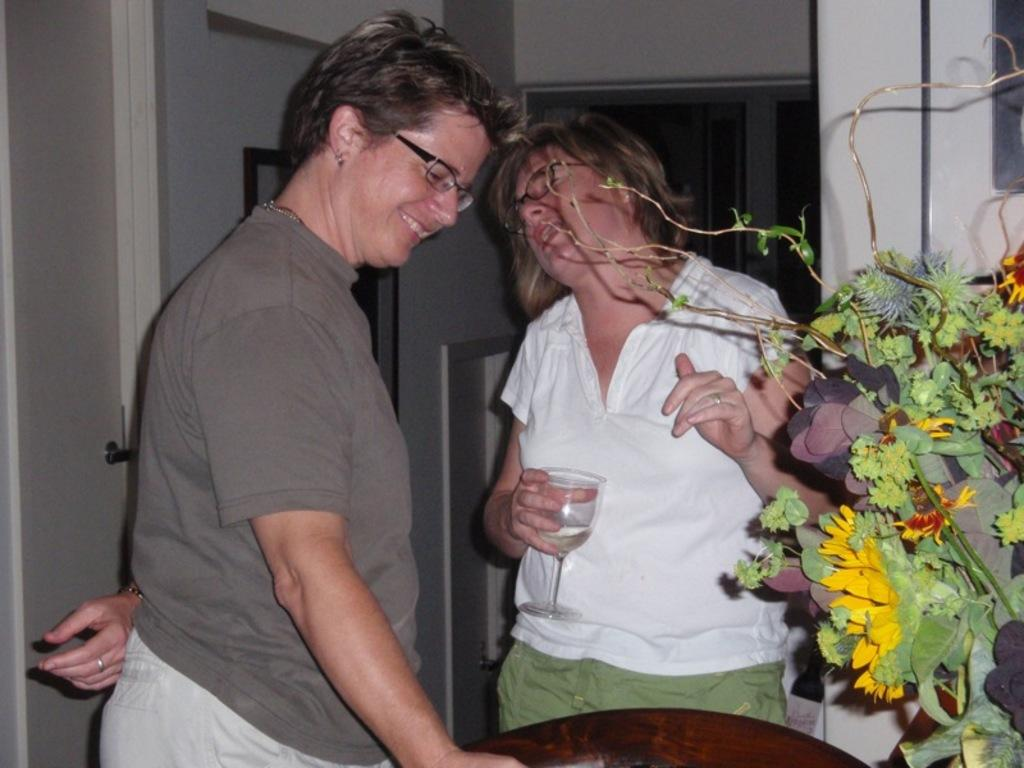How many people are in the image? There are two persons in the image. What is one of the persons holding? One of the persons is holding a glass. What can be seen in the image besides the people? There is a plant in the image, and it has a flower. What is visible in the background of the image? There is a wall in the background of the image. How many spiders are crawling on the persons in the image? There are no spiders visible in the image; it only features two persons, a plant with a flower, and a wall in the background. 